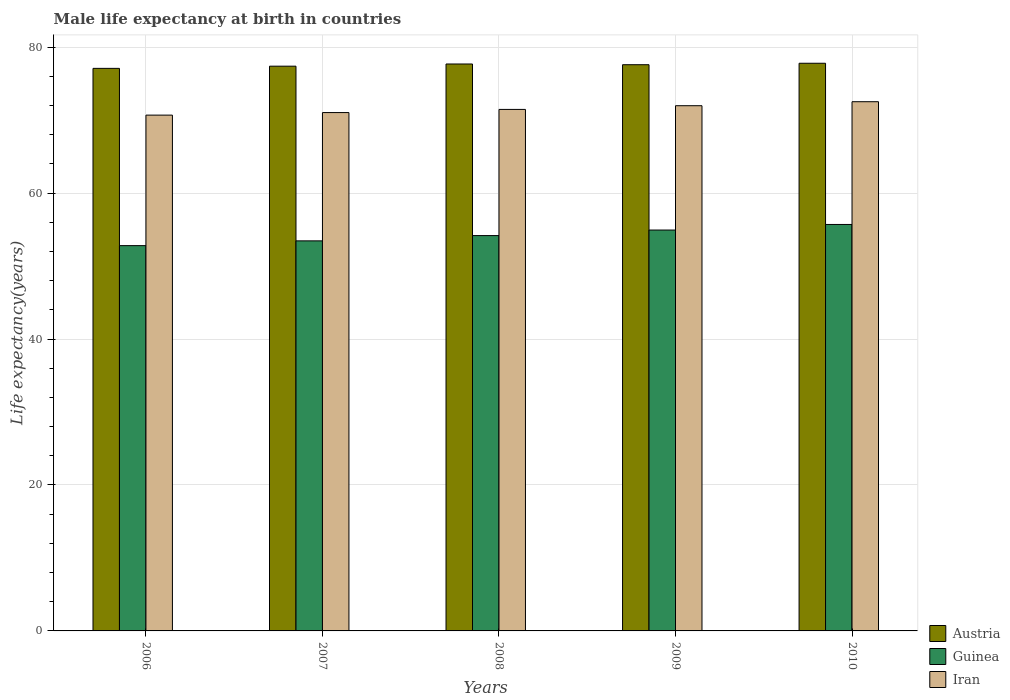How many different coloured bars are there?
Provide a short and direct response. 3. Are the number of bars on each tick of the X-axis equal?
Make the answer very short. Yes. How many bars are there on the 1st tick from the left?
Provide a short and direct response. 3. What is the label of the 5th group of bars from the left?
Ensure brevity in your answer.  2010. In how many cases, is the number of bars for a given year not equal to the number of legend labels?
Your answer should be compact. 0. What is the male life expectancy at birth in Austria in 2010?
Keep it short and to the point. 77.8. Across all years, what is the maximum male life expectancy at birth in Austria?
Keep it short and to the point. 77.8. Across all years, what is the minimum male life expectancy at birth in Guinea?
Offer a very short reply. 52.8. What is the total male life expectancy at birth in Austria in the graph?
Provide a succinct answer. 387.6. What is the difference between the male life expectancy at birth in Austria in 2008 and that in 2009?
Offer a terse response. 0.1. What is the difference between the male life expectancy at birth in Austria in 2009 and the male life expectancy at birth in Iran in 2006?
Your answer should be compact. 6.91. What is the average male life expectancy at birth in Austria per year?
Your response must be concise. 77.52. In the year 2007, what is the difference between the male life expectancy at birth in Guinea and male life expectancy at birth in Iran?
Your response must be concise. -17.58. In how many years, is the male life expectancy at birth in Iran greater than 32 years?
Provide a short and direct response. 5. What is the ratio of the male life expectancy at birth in Guinea in 2007 to that in 2010?
Provide a succinct answer. 0.96. Is the male life expectancy at birth in Iran in 2007 less than that in 2008?
Your answer should be very brief. Yes. What is the difference between the highest and the second highest male life expectancy at birth in Iran?
Give a very brief answer. 0.55. What is the difference between the highest and the lowest male life expectancy at birth in Guinea?
Your answer should be very brief. 2.9. What does the 3rd bar from the left in 2007 represents?
Keep it short and to the point. Iran. Is it the case that in every year, the sum of the male life expectancy at birth in Guinea and male life expectancy at birth in Austria is greater than the male life expectancy at birth in Iran?
Ensure brevity in your answer.  Yes. How many bars are there?
Offer a very short reply. 15. How many years are there in the graph?
Offer a terse response. 5. What is the difference between two consecutive major ticks on the Y-axis?
Provide a short and direct response. 20. Where does the legend appear in the graph?
Your response must be concise. Bottom right. What is the title of the graph?
Give a very brief answer. Male life expectancy at birth in countries. What is the label or title of the Y-axis?
Keep it short and to the point. Life expectancy(years). What is the Life expectancy(years) in Austria in 2006?
Offer a very short reply. 77.1. What is the Life expectancy(years) in Guinea in 2006?
Keep it short and to the point. 52.8. What is the Life expectancy(years) in Iran in 2006?
Offer a terse response. 70.69. What is the Life expectancy(years) in Austria in 2007?
Keep it short and to the point. 77.4. What is the Life expectancy(years) in Guinea in 2007?
Keep it short and to the point. 53.46. What is the Life expectancy(years) in Iran in 2007?
Provide a short and direct response. 71.04. What is the Life expectancy(years) in Austria in 2008?
Make the answer very short. 77.7. What is the Life expectancy(years) of Guinea in 2008?
Your answer should be very brief. 54.18. What is the Life expectancy(years) of Iran in 2008?
Keep it short and to the point. 71.47. What is the Life expectancy(years) of Austria in 2009?
Make the answer very short. 77.6. What is the Life expectancy(years) in Guinea in 2009?
Ensure brevity in your answer.  54.94. What is the Life expectancy(years) in Iran in 2009?
Provide a succinct answer. 71.98. What is the Life expectancy(years) of Austria in 2010?
Make the answer very short. 77.8. What is the Life expectancy(years) in Guinea in 2010?
Your answer should be compact. 55.71. What is the Life expectancy(years) in Iran in 2010?
Offer a terse response. 72.53. Across all years, what is the maximum Life expectancy(years) of Austria?
Your answer should be very brief. 77.8. Across all years, what is the maximum Life expectancy(years) in Guinea?
Provide a succinct answer. 55.71. Across all years, what is the maximum Life expectancy(years) of Iran?
Ensure brevity in your answer.  72.53. Across all years, what is the minimum Life expectancy(years) in Austria?
Your answer should be compact. 77.1. Across all years, what is the minimum Life expectancy(years) of Guinea?
Keep it short and to the point. 52.8. Across all years, what is the minimum Life expectancy(years) in Iran?
Ensure brevity in your answer.  70.69. What is the total Life expectancy(years) in Austria in the graph?
Keep it short and to the point. 387.6. What is the total Life expectancy(years) of Guinea in the graph?
Ensure brevity in your answer.  271.09. What is the total Life expectancy(years) in Iran in the graph?
Ensure brevity in your answer.  357.72. What is the difference between the Life expectancy(years) in Guinea in 2006 and that in 2007?
Your answer should be very brief. -0.65. What is the difference between the Life expectancy(years) in Iran in 2006 and that in 2007?
Your answer should be compact. -0.35. What is the difference between the Life expectancy(years) of Austria in 2006 and that in 2008?
Your answer should be compact. -0.6. What is the difference between the Life expectancy(years) in Guinea in 2006 and that in 2008?
Offer a very short reply. -1.38. What is the difference between the Life expectancy(years) in Iran in 2006 and that in 2008?
Provide a succinct answer. -0.78. What is the difference between the Life expectancy(years) of Austria in 2006 and that in 2009?
Give a very brief answer. -0.5. What is the difference between the Life expectancy(years) of Guinea in 2006 and that in 2009?
Your answer should be compact. -2.14. What is the difference between the Life expectancy(years) of Iran in 2006 and that in 2009?
Provide a short and direct response. -1.29. What is the difference between the Life expectancy(years) in Guinea in 2006 and that in 2010?
Give a very brief answer. -2.9. What is the difference between the Life expectancy(years) of Iran in 2006 and that in 2010?
Your answer should be compact. -1.84. What is the difference between the Life expectancy(years) in Austria in 2007 and that in 2008?
Ensure brevity in your answer.  -0.3. What is the difference between the Life expectancy(years) in Guinea in 2007 and that in 2008?
Your answer should be very brief. -0.72. What is the difference between the Life expectancy(years) of Iran in 2007 and that in 2008?
Keep it short and to the point. -0.43. What is the difference between the Life expectancy(years) of Guinea in 2007 and that in 2009?
Offer a very short reply. -1.48. What is the difference between the Life expectancy(years) in Iran in 2007 and that in 2009?
Your answer should be very brief. -0.94. What is the difference between the Life expectancy(years) of Austria in 2007 and that in 2010?
Your answer should be very brief. -0.4. What is the difference between the Life expectancy(years) of Guinea in 2007 and that in 2010?
Your answer should be compact. -2.25. What is the difference between the Life expectancy(years) in Iran in 2007 and that in 2010?
Provide a succinct answer. -1.49. What is the difference between the Life expectancy(years) in Guinea in 2008 and that in 2009?
Ensure brevity in your answer.  -0.76. What is the difference between the Life expectancy(years) of Iran in 2008 and that in 2009?
Give a very brief answer. -0.51. What is the difference between the Life expectancy(years) of Guinea in 2008 and that in 2010?
Provide a succinct answer. -1.53. What is the difference between the Life expectancy(years) in Iran in 2008 and that in 2010?
Your response must be concise. -1.05. What is the difference between the Life expectancy(years) in Austria in 2009 and that in 2010?
Give a very brief answer. -0.2. What is the difference between the Life expectancy(years) in Guinea in 2009 and that in 2010?
Ensure brevity in your answer.  -0.77. What is the difference between the Life expectancy(years) of Iran in 2009 and that in 2010?
Your response must be concise. -0.55. What is the difference between the Life expectancy(years) of Austria in 2006 and the Life expectancy(years) of Guinea in 2007?
Offer a terse response. 23.64. What is the difference between the Life expectancy(years) of Austria in 2006 and the Life expectancy(years) of Iran in 2007?
Your answer should be very brief. 6.06. What is the difference between the Life expectancy(years) in Guinea in 2006 and the Life expectancy(years) in Iran in 2007?
Ensure brevity in your answer.  -18.24. What is the difference between the Life expectancy(years) of Austria in 2006 and the Life expectancy(years) of Guinea in 2008?
Your answer should be compact. 22.92. What is the difference between the Life expectancy(years) of Austria in 2006 and the Life expectancy(years) of Iran in 2008?
Your response must be concise. 5.62. What is the difference between the Life expectancy(years) in Guinea in 2006 and the Life expectancy(years) in Iran in 2008?
Your answer should be compact. -18.67. What is the difference between the Life expectancy(years) in Austria in 2006 and the Life expectancy(years) in Guinea in 2009?
Provide a short and direct response. 22.16. What is the difference between the Life expectancy(years) in Austria in 2006 and the Life expectancy(years) in Iran in 2009?
Your answer should be very brief. 5.12. What is the difference between the Life expectancy(years) in Guinea in 2006 and the Life expectancy(years) in Iran in 2009?
Ensure brevity in your answer.  -19.18. What is the difference between the Life expectancy(years) in Austria in 2006 and the Life expectancy(years) in Guinea in 2010?
Keep it short and to the point. 21.39. What is the difference between the Life expectancy(years) of Austria in 2006 and the Life expectancy(years) of Iran in 2010?
Your answer should be compact. 4.57. What is the difference between the Life expectancy(years) of Guinea in 2006 and the Life expectancy(years) of Iran in 2010?
Your response must be concise. -19.73. What is the difference between the Life expectancy(years) of Austria in 2007 and the Life expectancy(years) of Guinea in 2008?
Keep it short and to the point. 23.22. What is the difference between the Life expectancy(years) of Austria in 2007 and the Life expectancy(years) of Iran in 2008?
Your answer should be compact. 5.92. What is the difference between the Life expectancy(years) of Guinea in 2007 and the Life expectancy(years) of Iran in 2008?
Make the answer very short. -18.02. What is the difference between the Life expectancy(years) of Austria in 2007 and the Life expectancy(years) of Guinea in 2009?
Offer a terse response. 22.46. What is the difference between the Life expectancy(years) of Austria in 2007 and the Life expectancy(years) of Iran in 2009?
Give a very brief answer. 5.42. What is the difference between the Life expectancy(years) in Guinea in 2007 and the Life expectancy(years) in Iran in 2009?
Provide a short and direct response. -18.52. What is the difference between the Life expectancy(years) of Austria in 2007 and the Life expectancy(years) of Guinea in 2010?
Ensure brevity in your answer.  21.69. What is the difference between the Life expectancy(years) of Austria in 2007 and the Life expectancy(years) of Iran in 2010?
Ensure brevity in your answer.  4.87. What is the difference between the Life expectancy(years) in Guinea in 2007 and the Life expectancy(years) in Iran in 2010?
Ensure brevity in your answer.  -19.07. What is the difference between the Life expectancy(years) in Austria in 2008 and the Life expectancy(years) in Guinea in 2009?
Offer a very short reply. 22.76. What is the difference between the Life expectancy(years) in Austria in 2008 and the Life expectancy(years) in Iran in 2009?
Offer a terse response. 5.72. What is the difference between the Life expectancy(years) of Guinea in 2008 and the Life expectancy(years) of Iran in 2009?
Keep it short and to the point. -17.8. What is the difference between the Life expectancy(years) in Austria in 2008 and the Life expectancy(years) in Guinea in 2010?
Give a very brief answer. 21.99. What is the difference between the Life expectancy(years) in Austria in 2008 and the Life expectancy(years) in Iran in 2010?
Your response must be concise. 5.17. What is the difference between the Life expectancy(years) of Guinea in 2008 and the Life expectancy(years) of Iran in 2010?
Ensure brevity in your answer.  -18.35. What is the difference between the Life expectancy(years) of Austria in 2009 and the Life expectancy(years) of Guinea in 2010?
Make the answer very short. 21.89. What is the difference between the Life expectancy(years) in Austria in 2009 and the Life expectancy(years) in Iran in 2010?
Ensure brevity in your answer.  5.07. What is the difference between the Life expectancy(years) in Guinea in 2009 and the Life expectancy(years) in Iran in 2010?
Make the answer very short. -17.59. What is the average Life expectancy(years) in Austria per year?
Give a very brief answer. 77.52. What is the average Life expectancy(years) of Guinea per year?
Your response must be concise. 54.22. What is the average Life expectancy(years) in Iran per year?
Keep it short and to the point. 71.54. In the year 2006, what is the difference between the Life expectancy(years) in Austria and Life expectancy(years) in Guinea?
Keep it short and to the point. 24.3. In the year 2006, what is the difference between the Life expectancy(years) of Austria and Life expectancy(years) of Iran?
Provide a short and direct response. 6.41. In the year 2006, what is the difference between the Life expectancy(years) of Guinea and Life expectancy(years) of Iran?
Make the answer very short. -17.89. In the year 2007, what is the difference between the Life expectancy(years) of Austria and Life expectancy(years) of Guinea?
Keep it short and to the point. 23.94. In the year 2007, what is the difference between the Life expectancy(years) of Austria and Life expectancy(years) of Iran?
Give a very brief answer. 6.36. In the year 2007, what is the difference between the Life expectancy(years) in Guinea and Life expectancy(years) in Iran?
Your response must be concise. -17.58. In the year 2008, what is the difference between the Life expectancy(years) in Austria and Life expectancy(years) in Guinea?
Your response must be concise. 23.52. In the year 2008, what is the difference between the Life expectancy(years) in Austria and Life expectancy(years) in Iran?
Provide a succinct answer. 6.22. In the year 2008, what is the difference between the Life expectancy(years) of Guinea and Life expectancy(years) of Iran?
Provide a short and direct response. -17.29. In the year 2009, what is the difference between the Life expectancy(years) in Austria and Life expectancy(years) in Guinea?
Your answer should be compact. 22.66. In the year 2009, what is the difference between the Life expectancy(years) of Austria and Life expectancy(years) of Iran?
Provide a short and direct response. 5.62. In the year 2009, what is the difference between the Life expectancy(years) in Guinea and Life expectancy(years) in Iran?
Your answer should be very brief. -17.04. In the year 2010, what is the difference between the Life expectancy(years) in Austria and Life expectancy(years) in Guinea?
Ensure brevity in your answer.  22.09. In the year 2010, what is the difference between the Life expectancy(years) in Austria and Life expectancy(years) in Iran?
Your answer should be very brief. 5.27. In the year 2010, what is the difference between the Life expectancy(years) in Guinea and Life expectancy(years) in Iran?
Keep it short and to the point. -16.82. What is the ratio of the Life expectancy(years) of Austria in 2006 to that in 2007?
Provide a short and direct response. 1. What is the ratio of the Life expectancy(years) in Guinea in 2006 to that in 2008?
Offer a very short reply. 0.97. What is the ratio of the Life expectancy(years) in Iran in 2006 to that in 2008?
Ensure brevity in your answer.  0.99. What is the ratio of the Life expectancy(years) of Guinea in 2006 to that in 2009?
Keep it short and to the point. 0.96. What is the ratio of the Life expectancy(years) of Iran in 2006 to that in 2009?
Provide a short and direct response. 0.98. What is the ratio of the Life expectancy(years) in Austria in 2006 to that in 2010?
Provide a short and direct response. 0.99. What is the ratio of the Life expectancy(years) in Guinea in 2006 to that in 2010?
Offer a very short reply. 0.95. What is the ratio of the Life expectancy(years) in Iran in 2006 to that in 2010?
Provide a succinct answer. 0.97. What is the ratio of the Life expectancy(years) of Austria in 2007 to that in 2008?
Your response must be concise. 1. What is the ratio of the Life expectancy(years) of Guinea in 2007 to that in 2008?
Keep it short and to the point. 0.99. What is the ratio of the Life expectancy(years) of Austria in 2007 to that in 2009?
Provide a short and direct response. 1. What is the ratio of the Life expectancy(years) of Guinea in 2007 to that in 2010?
Provide a short and direct response. 0.96. What is the ratio of the Life expectancy(years) of Iran in 2007 to that in 2010?
Make the answer very short. 0.98. What is the ratio of the Life expectancy(years) in Guinea in 2008 to that in 2009?
Ensure brevity in your answer.  0.99. What is the ratio of the Life expectancy(years) of Iran in 2008 to that in 2009?
Make the answer very short. 0.99. What is the ratio of the Life expectancy(years) in Guinea in 2008 to that in 2010?
Provide a short and direct response. 0.97. What is the ratio of the Life expectancy(years) of Iran in 2008 to that in 2010?
Make the answer very short. 0.99. What is the ratio of the Life expectancy(years) in Austria in 2009 to that in 2010?
Keep it short and to the point. 1. What is the ratio of the Life expectancy(years) of Guinea in 2009 to that in 2010?
Offer a terse response. 0.99. What is the difference between the highest and the second highest Life expectancy(years) in Guinea?
Provide a short and direct response. 0.77. What is the difference between the highest and the second highest Life expectancy(years) of Iran?
Provide a short and direct response. 0.55. What is the difference between the highest and the lowest Life expectancy(years) of Austria?
Provide a short and direct response. 0.7. What is the difference between the highest and the lowest Life expectancy(years) of Guinea?
Provide a succinct answer. 2.9. What is the difference between the highest and the lowest Life expectancy(years) in Iran?
Your response must be concise. 1.84. 